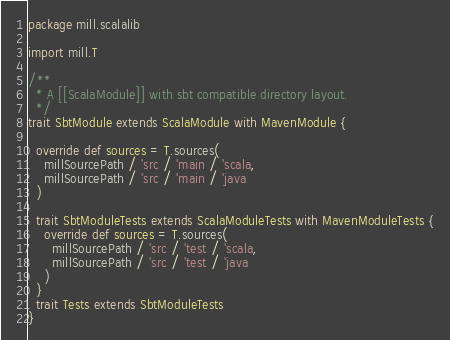<code> <loc_0><loc_0><loc_500><loc_500><_Scala_>package mill.scalalib

import mill.T

/**
  * A [[ScalaModule]] with sbt compatible directory layout.
  */
trait SbtModule extends ScalaModule with MavenModule {

  override def sources = T.sources(
    millSourcePath / 'src / 'main / 'scala,
    millSourcePath / 'src / 'main / 'java
  )

  trait SbtModuleTests extends ScalaModuleTests with MavenModuleTests {
    override def sources = T.sources(
      millSourcePath / 'src / 'test / 'scala,
      millSourcePath / 'src / 'test / 'java
    )
  }
  trait Tests extends SbtModuleTests
}
</code> 